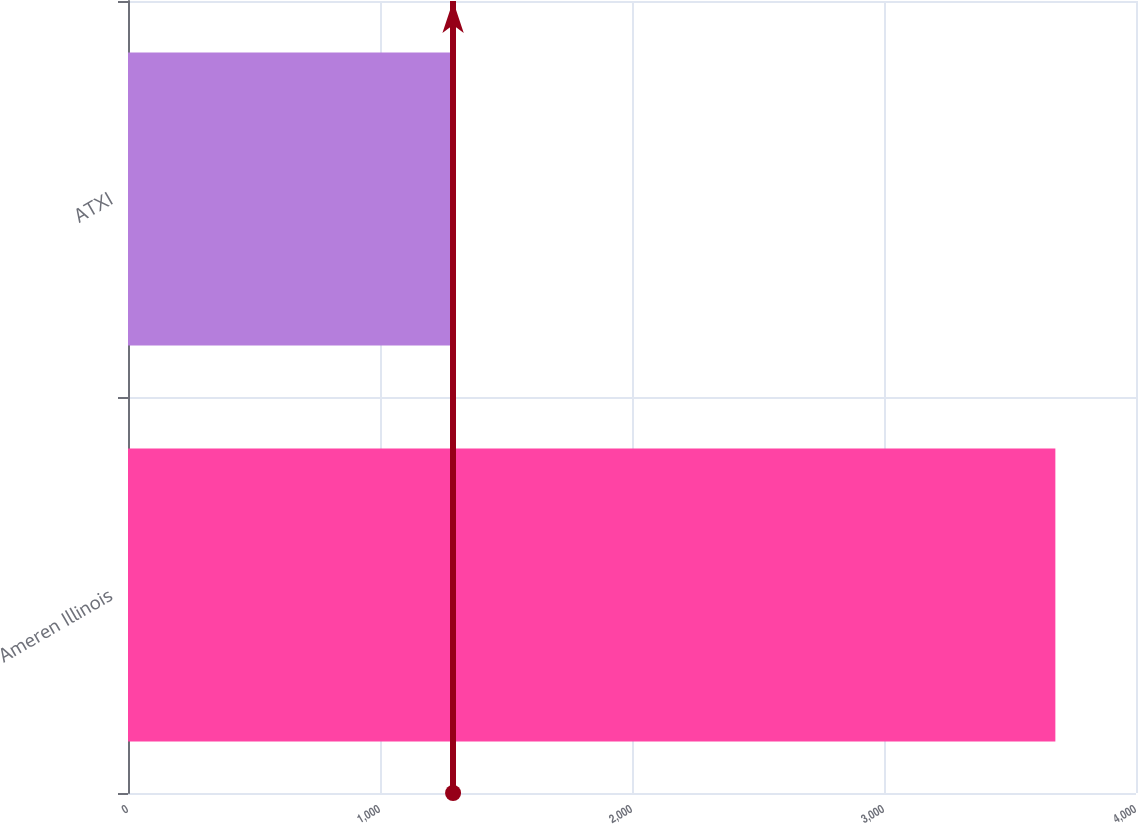<chart> <loc_0><loc_0><loc_500><loc_500><bar_chart><fcel>Ameren Illinois<fcel>ATXI<nl><fcel>3680<fcel>1290<nl></chart> 